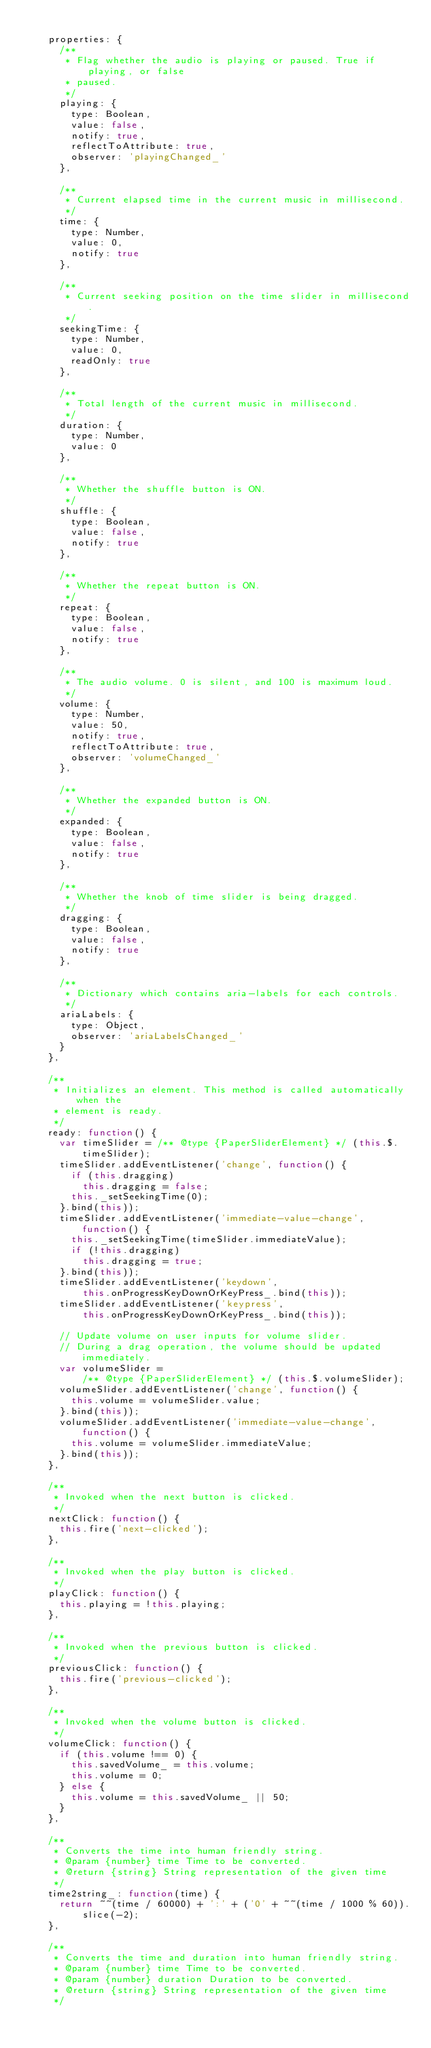<code> <loc_0><loc_0><loc_500><loc_500><_JavaScript_>
    properties: {
      /**
       * Flag whether the audio is playing or paused. True if playing, or false
       * paused.
       */
      playing: {
        type: Boolean,
        value: false,
        notify: true,
        reflectToAttribute: true,
        observer: 'playingChanged_'
      },

      /**
       * Current elapsed time in the current music in millisecond.
       */
      time: {
        type: Number,
        value: 0,
        notify: true
      },

      /**
       * Current seeking position on the time slider in millisecond.
       */
      seekingTime: {
        type: Number,
        value: 0,
        readOnly: true
      },

      /**
       * Total length of the current music in millisecond.
       */
      duration: {
        type: Number,
        value: 0
      },

      /**
       * Whether the shuffle button is ON.
       */
      shuffle: {
        type: Boolean,
        value: false,
        notify: true
      },

      /**
       * Whether the repeat button is ON.
       */
      repeat: {
        type: Boolean,
        value: false,
        notify: true
      },

      /**
       * The audio volume. 0 is silent, and 100 is maximum loud.
       */
      volume: {
        type: Number,
        value: 50,
        notify: true,
        reflectToAttribute: true,
        observer: 'volumeChanged_'
      },

      /**
       * Whether the expanded button is ON.
       */
      expanded: {
        type: Boolean,
        value: false,
        notify: true
      },

      /**
       * Whether the knob of time slider is being dragged.
       */
      dragging: {
        type: Boolean,
        value: false,
        notify: true
      },

      /**
       * Dictionary which contains aria-labels for each controls.
       */
      ariaLabels: {
        type: Object,
        observer: 'ariaLabelsChanged_'
      }
    },

    /**
     * Initializes an element. This method is called automatically when the
     * element is ready.
     */
    ready: function() {
      var timeSlider = /** @type {PaperSliderElement} */ (this.$.timeSlider);
      timeSlider.addEventListener('change', function() {
        if (this.dragging)
          this.dragging = false;
        this._setSeekingTime(0);
      }.bind(this));
      timeSlider.addEventListener('immediate-value-change', function() {
        this._setSeekingTime(timeSlider.immediateValue);
        if (!this.dragging)
          this.dragging = true;
      }.bind(this));
      timeSlider.addEventListener('keydown',
          this.onProgressKeyDownOrKeyPress_.bind(this));
      timeSlider.addEventListener('keypress',
          this.onProgressKeyDownOrKeyPress_.bind(this));

      // Update volume on user inputs for volume slider.
      // During a drag operation, the volume should be updated immediately.
      var volumeSlider =
          /** @type {PaperSliderElement} */ (this.$.volumeSlider);
      volumeSlider.addEventListener('change', function() {
        this.volume = volumeSlider.value;
      }.bind(this));
      volumeSlider.addEventListener('immediate-value-change', function() {
        this.volume = volumeSlider.immediateValue;
      }.bind(this));
    },

    /**
     * Invoked when the next button is clicked.
     */
    nextClick: function() {
      this.fire('next-clicked');
    },

    /**
     * Invoked when the play button is clicked.
     */
    playClick: function() {
      this.playing = !this.playing;
    },

    /**
     * Invoked when the previous button is clicked.
     */
    previousClick: function() {
      this.fire('previous-clicked');
    },

    /**
     * Invoked when the volume button is clicked.
     */
    volumeClick: function() {
      if (this.volume !== 0) {
        this.savedVolume_ = this.volume;
        this.volume = 0;
      } else {
        this.volume = this.savedVolume_ || 50;
      }
    },

    /**
     * Converts the time into human friendly string.
     * @param {number} time Time to be converted.
     * @return {string} String representation of the given time
     */
    time2string_: function(time) {
      return ~~(time / 60000) + ':' + ('0' + ~~(time / 1000 % 60)).slice(-2);
    },

    /**
     * Converts the time and duration into human friendly string.
     * @param {number} time Time to be converted.
     * @param {number} duration Duration to be converted.
     * @return {string} String representation of the given time
     */</code> 